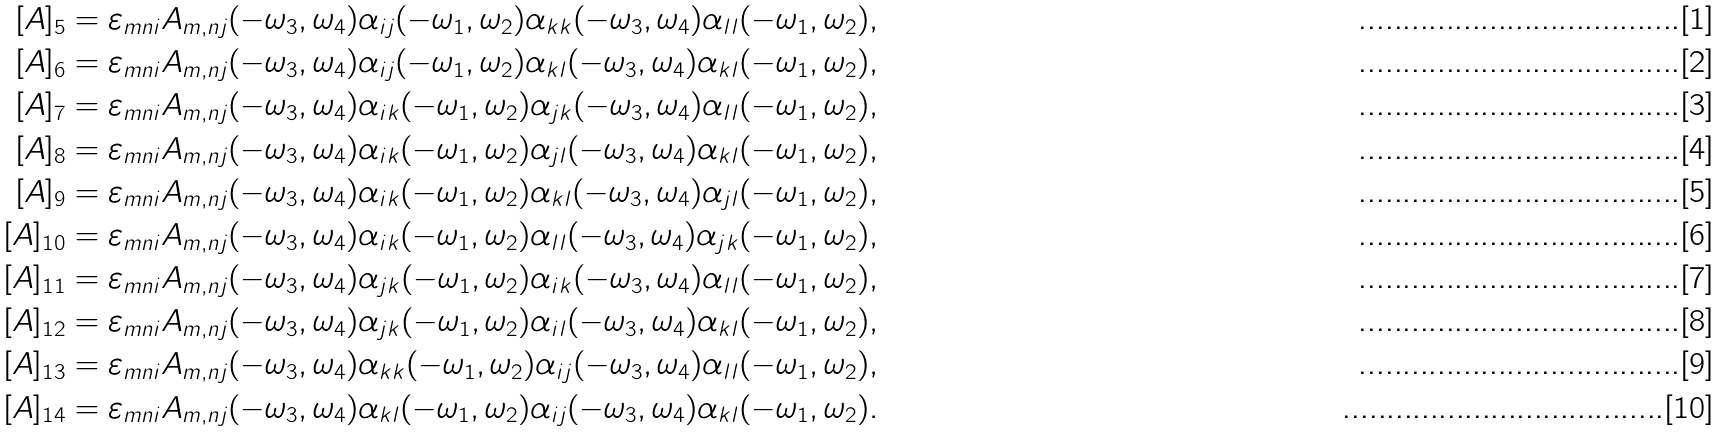Convert formula to latex. <formula><loc_0><loc_0><loc_500><loc_500>[ A ] _ { 5 } & = \varepsilon _ { m n i } A _ { m , n j } ( - \omega _ { 3 } , \omega _ { 4 } ) \alpha _ { i j } ( - \omega _ { 1 } , \omega _ { 2 } ) \alpha _ { k k } ( - \omega _ { 3 } , \omega _ { 4 } ) \alpha _ { l l } ( - \omega _ { 1 } , \omega _ { 2 } ) , \\ [ A ] _ { 6 } & = \varepsilon _ { m n i } A _ { m , n j } ( - \omega _ { 3 } , \omega _ { 4 } ) \alpha _ { i j } ( - \omega _ { 1 } , \omega _ { 2 } ) \alpha _ { k l } ( - \omega _ { 3 } , \omega _ { 4 } ) \alpha _ { k l } ( - \omega _ { 1 } , \omega _ { 2 } ) , \\ [ A ] _ { 7 } & = \varepsilon _ { m n i } A _ { m , n j } ( - \omega _ { 3 } , \omega _ { 4 } ) \alpha _ { i k } ( - \omega _ { 1 } , \omega _ { 2 } ) \alpha _ { j k } ( - \omega _ { 3 } , \omega _ { 4 } ) \alpha _ { l l } ( - \omega _ { 1 } , \omega _ { 2 } ) , \\ [ A ] _ { 8 } & = \varepsilon _ { m n i } A _ { m , n j } ( - \omega _ { 3 } , \omega _ { 4 } ) \alpha _ { i k } ( - \omega _ { 1 } , \omega _ { 2 } ) \alpha _ { j l } ( - \omega _ { 3 } , \omega _ { 4 } ) \alpha _ { k l } ( - \omega _ { 1 } , \omega _ { 2 } ) , \\ [ A ] _ { 9 } & = \varepsilon _ { m n i } A _ { m , n j } ( - \omega _ { 3 } , \omega _ { 4 } ) \alpha _ { i k } ( - \omega _ { 1 } , \omega _ { 2 } ) \alpha _ { k l } ( - \omega _ { 3 } , \omega _ { 4 } ) \alpha _ { j l } ( - \omega _ { 1 } , \omega _ { 2 } ) , \\ [ A ] _ { 1 0 } & = \varepsilon _ { m n i } A _ { m , n j } ( - \omega _ { 3 } , \omega _ { 4 } ) \alpha _ { i k } ( - \omega _ { 1 } , \omega _ { 2 } ) \alpha _ { l l } ( - \omega _ { 3 } , \omega _ { 4 } ) \alpha _ { j k } ( - \omega _ { 1 } , \omega _ { 2 } ) , \\ [ A ] _ { 1 1 } & = \varepsilon _ { m n i } A _ { m , n j } ( - \omega _ { 3 } , \omega _ { 4 } ) \alpha _ { j k } ( - \omega _ { 1 } , \omega _ { 2 } ) \alpha _ { i k } ( - \omega _ { 3 } , \omega _ { 4 } ) \alpha _ { l l } ( - \omega _ { 1 } , \omega _ { 2 } ) , \\ [ A ] _ { 1 2 } & = \varepsilon _ { m n i } A _ { m , n j } ( - \omega _ { 3 } , \omega _ { 4 } ) \alpha _ { j k } ( - \omega _ { 1 } , \omega _ { 2 } ) \alpha _ { i l } ( - \omega _ { 3 } , \omega _ { 4 } ) \alpha _ { k l } ( - \omega _ { 1 } , \omega _ { 2 } ) , \\ [ A ] _ { 1 3 } & = \varepsilon _ { m n i } A _ { m , n j } ( - \omega _ { 3 } , \omega _ { 4 } ) \alpha _ { k k } ( - \omega _ { 1 } , \omega _ { 2 } ) \alpha _ { i j } ( - \omega _ { 3 } , \omega _ { 4 } ) \alpha _ { l l } ( - \omega _ { 1 } , \omega _ { 2 } ) , \\ [ A ] _ { 1 4 } & = \varepsilon _ { m n i } A _ { m , n j } ( - \omega _ { 3 } , \omega _ { 4 } ) \alpha _ { k l } ( - \omega _ { 1 } , \omega _ { 2 } ) \alpha _ { i j } ( - \omega _ { 3 } , \omega _ { 4 } ) \alpha _ { k l } ( - \omega _ { 1 } , \omega _ { 2 } ) .</formula> 